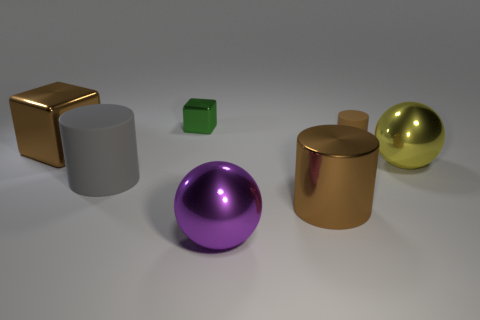Add 2 blue blocks. How many objects exist? 9 Subtract all big gray rubber cylinders. How many cylinders are left? 2 Subtract all gray cylinders. How many cylinders are left? 2 Subtract 2 cylinders. How many cylinders are left? 1 Subtract all cylinders. How many objects are left? 4 Subtract all cyan blocks. How many yellow spheres are left? 1 Subtract all shiny cylinders. Subtract all tiny blue cylinders. How many objects are left? 6 Add 7 yellow balls. How many yellow balls are left? 8 Add 1 small green metal things. How many small green metal things exist? 2 Subtract 0 brown spheres. How many objects are left? 7 